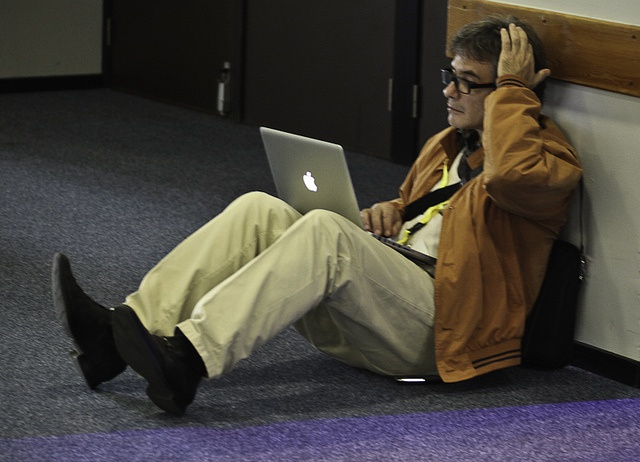Describe the objects in this image and their specific colors. I can see people in black, tan, and maroon tones, laptop in black, gray, and darkgreen tones, backpack in black and gray tones, handbag in black and gray tones, and tie in black and gray tones in this image. 